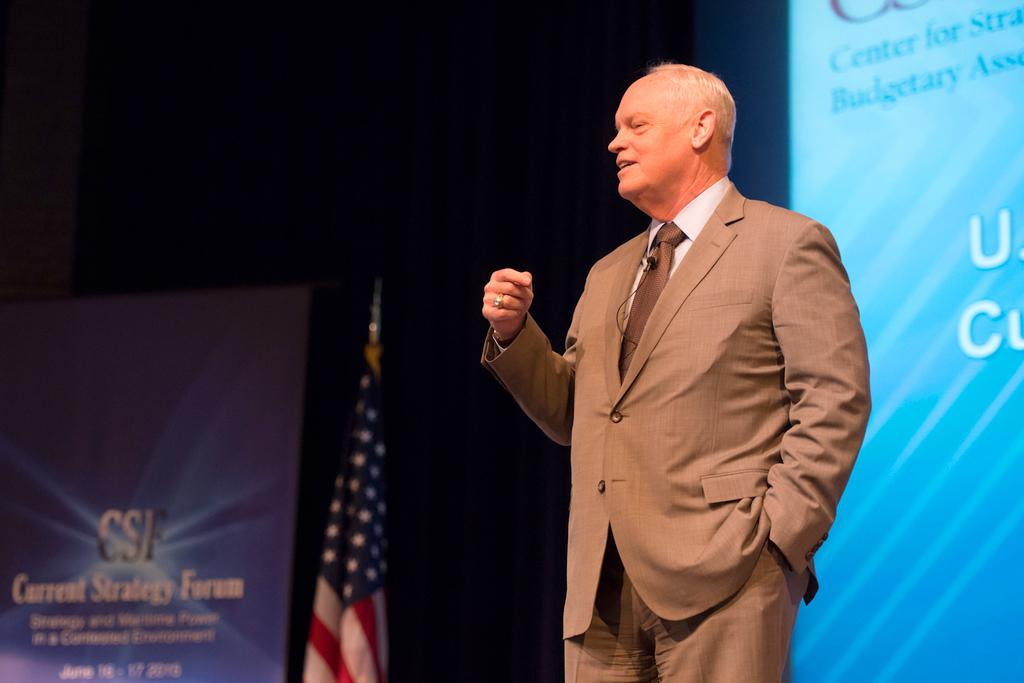What is the man in the image doing? The man is standing in the image. What is the man wearing? The man is wearing a suit. What can be seen in the background of the image? There is a screen, a banner, and a flag in the background of the image. What type of field can be seen in the image? There is no field present in the image. What is the man smashing in the image? The man is not smashing anything in the image; he is simply standing. 